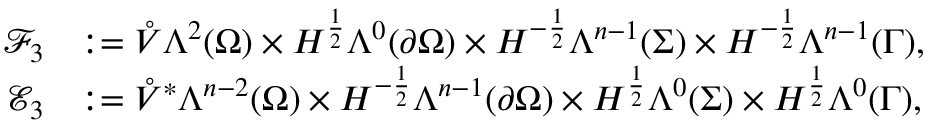<formula> <loc_0><loc_0><loc_500><loc_500>\begin{array} { r l } { \mathcal { F } _ { 3 } } & { \colon = \mathring { V } \Lambda ^ { 2 } ( \Omega ) \times H ^ { \frac { 1 } { 2 } } \Lambda ^ { 0 } ( \partial \Omega ) \times H ^ { - \frac { 1 } { 2 } } \Lambda ^ { n - 1 } ( \Sigma ) \times H ^ { - \frac { 1 } { 2 } } \Lambda ^ { n - 1 } ( \Gamma ) , } \\ { \mathcal { E } _ { 3 } } & { \colon = \mathring { V } ^ { \ast } \Lambda ^ { n - 2 } ( \Omega ) \times H ^ { - \frac { 1 } { 2 } } \Lambda ^ { n - 1 } ( \partial \Omega ) \times H ^ { \frac { 1 } { 2 } } \Lambda ^ { 0 } ( \Sigma ) \times H ^ { \frac { 1 } { 2 } } \Lambda ^ { 0 } ( \Gamma ) , } \end{array}</formula> 